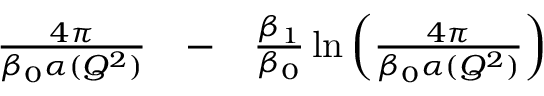Convert formula to latex. <formula><loc_0><loc_0><loc_500><loc_500>\begin{array} { r l r } { { \frac { 4 \pi } { \beta _ { 0 } \alpha ( Q ^ { 2 } ) } } } & - } & { { \frac { \beta _ { 1 } } { \beta _ { 0 } } } \ln \left ( { \frac { 4 \pi } { \beta _ { 0 } \alpha ( Q ^ { 2 } ) } } \right ) } \end{array}</formula> 